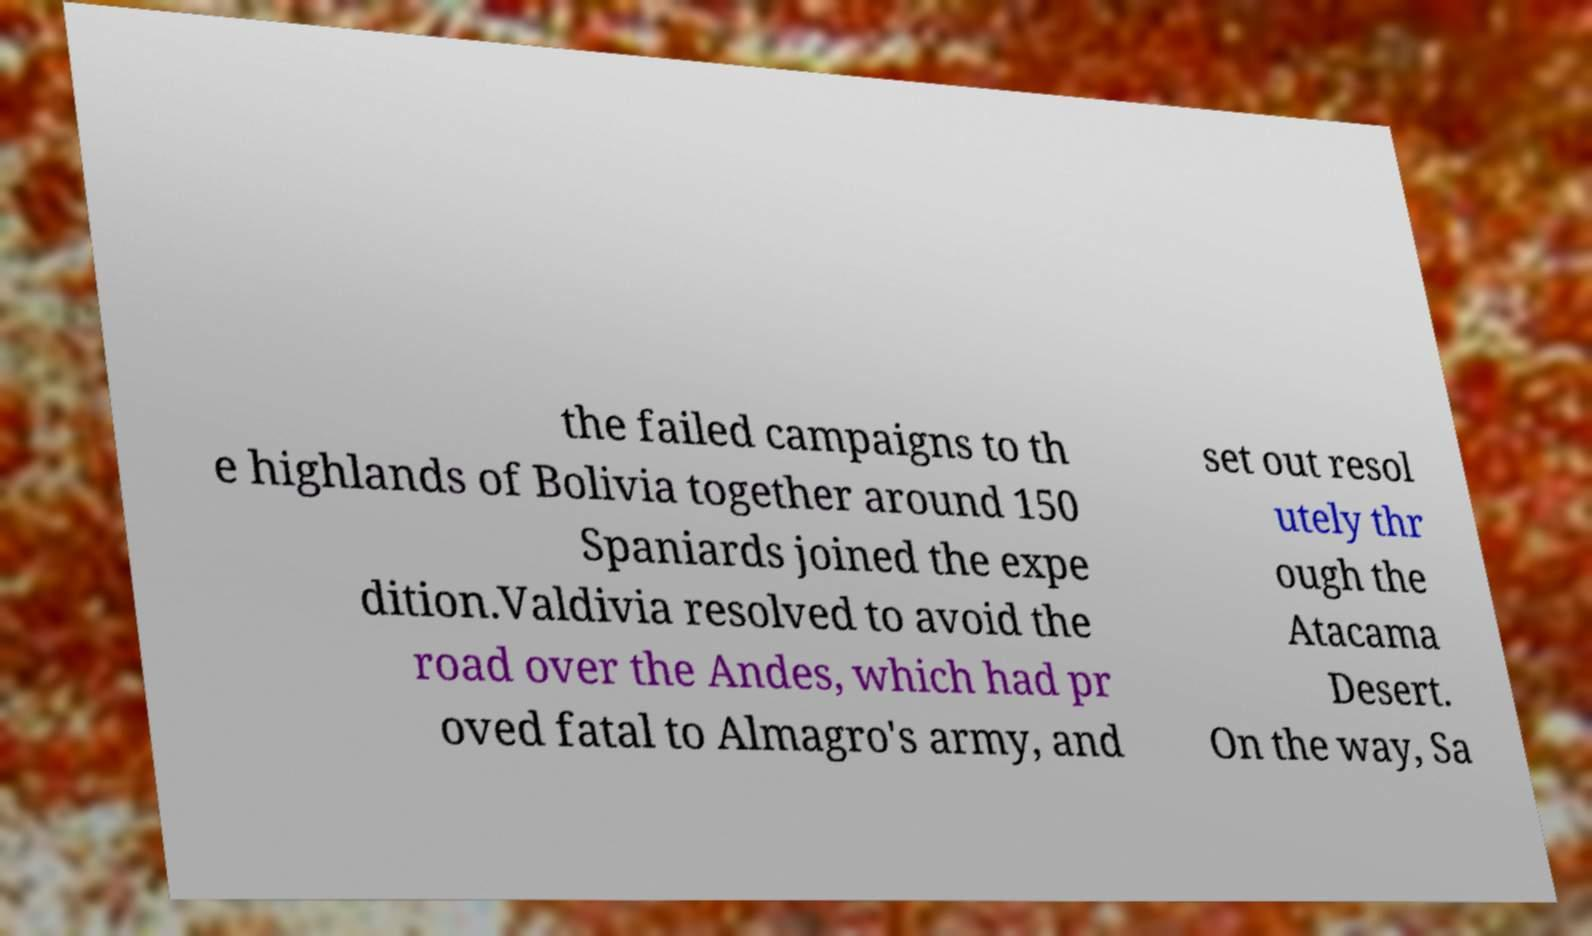Could you extract and type out the text from this image? the failed campaigns to th e highlands of Bolivia together around 150 Spaniards joined the expe dition.Valdivia resolved to avoid the road over the Andes, which had pr oved fatal to Almagro's army, and set out resol utely thr ough the Atacama Desert. On the way, Sa 